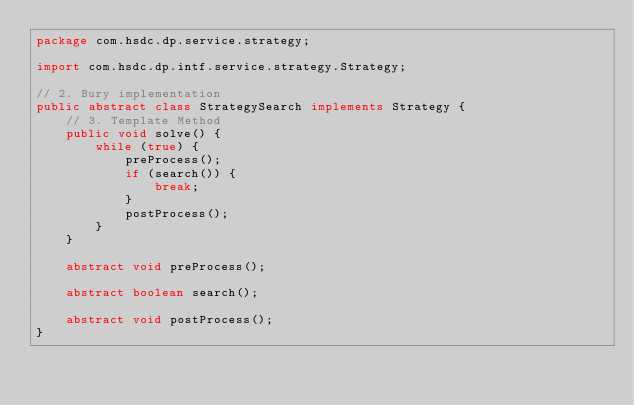<code> <loc_0><loc_0><loc_500><loc_500><_Java_>package com.hsdc.dp.service.strategy;

import com.hsdc.dp.intf.service.strategy.Strategy;

// 2. Bury implementation
public abstract class StrategySearch implements Strategy {
	// 3. Template Method
	public void solve() {
		while (true) {
			preProcess();
			if (search()) {
				break;
			}
			postProcess();
		}
	}

	abstract void preProcess();

	abstract boolean search();

	abstract void postProcess();
}
</code> 